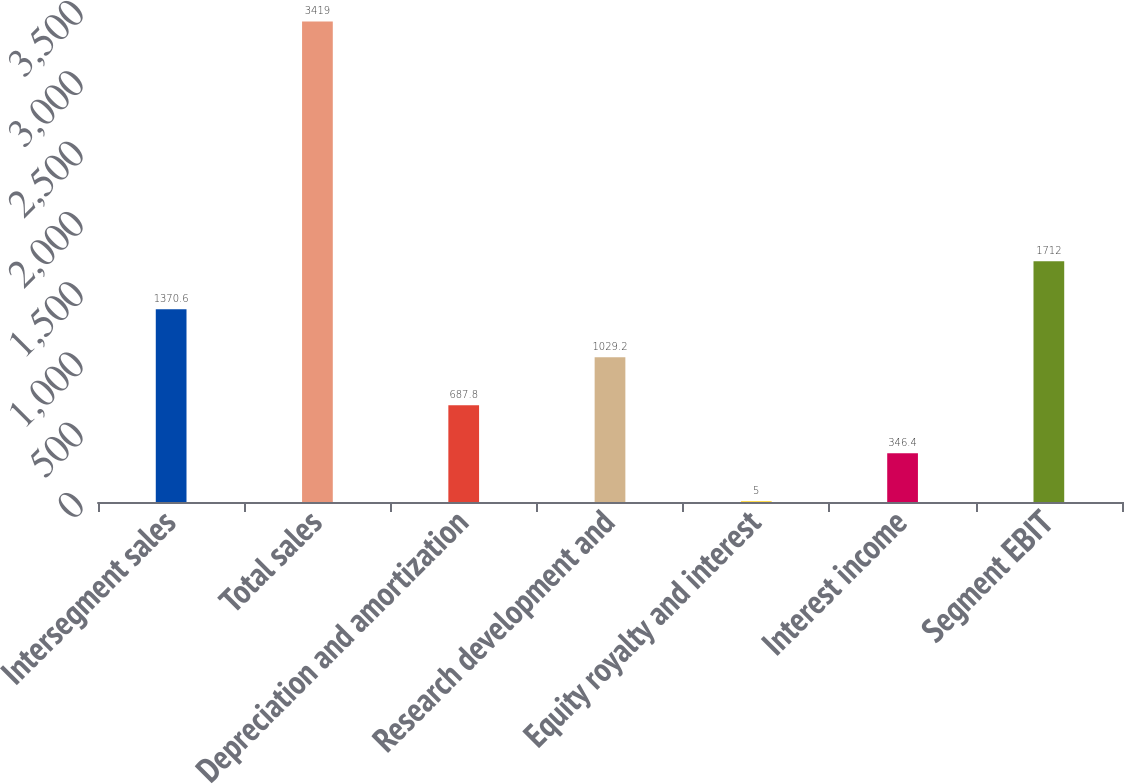Convert chart to OTSL. <chart><loc_0><loc_0><loc_500><loc_500><bar_chart><fcel>Intersegment sales<fcel>Total sales<fcel>Depreciation and amortization<fcel>Research development and<fcel>Equity royalty and interest<fcel>Interest income<fcel>Segment EBIT<nl><fcel>1370.6<fcel>3419<fcel>687.8<fcel>1029.2<fcel>5<fcel>346.4<fcel>1712<nl></chart> 